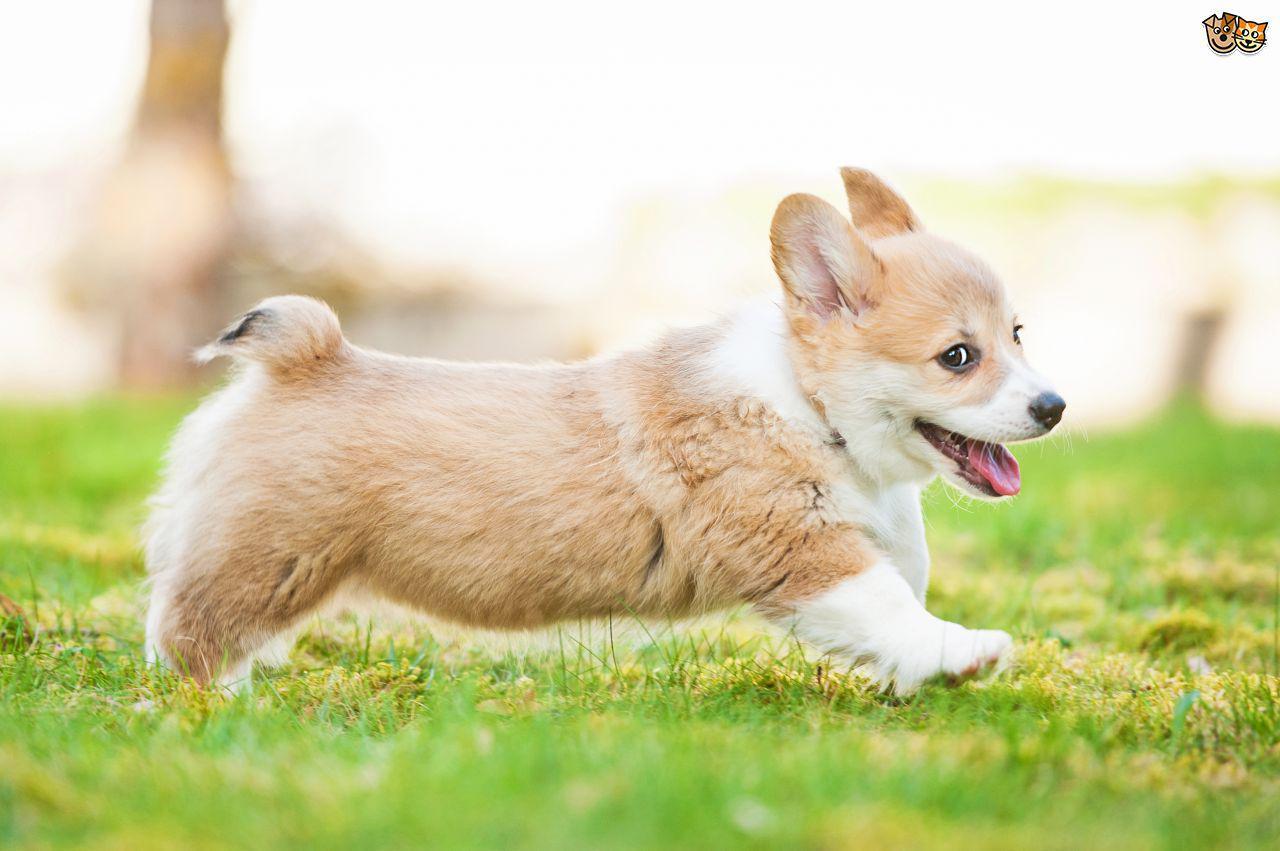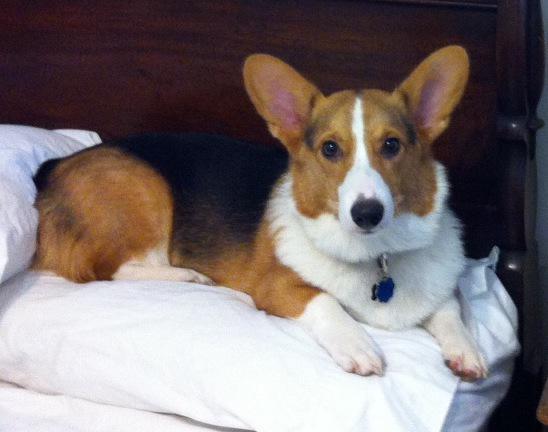The first image is the image on the left, the second image is the image on the right. Considering the images on both sides, is "At least one dog is sitting." valid? Answer yes or no. No. The first image is the image on the left, the second image is the image on the right. Evaluate the accuracy of this statement regarding the images: "A dog is stationary with their tongue hanging out.". Is it true? Answer yes or no. No. 